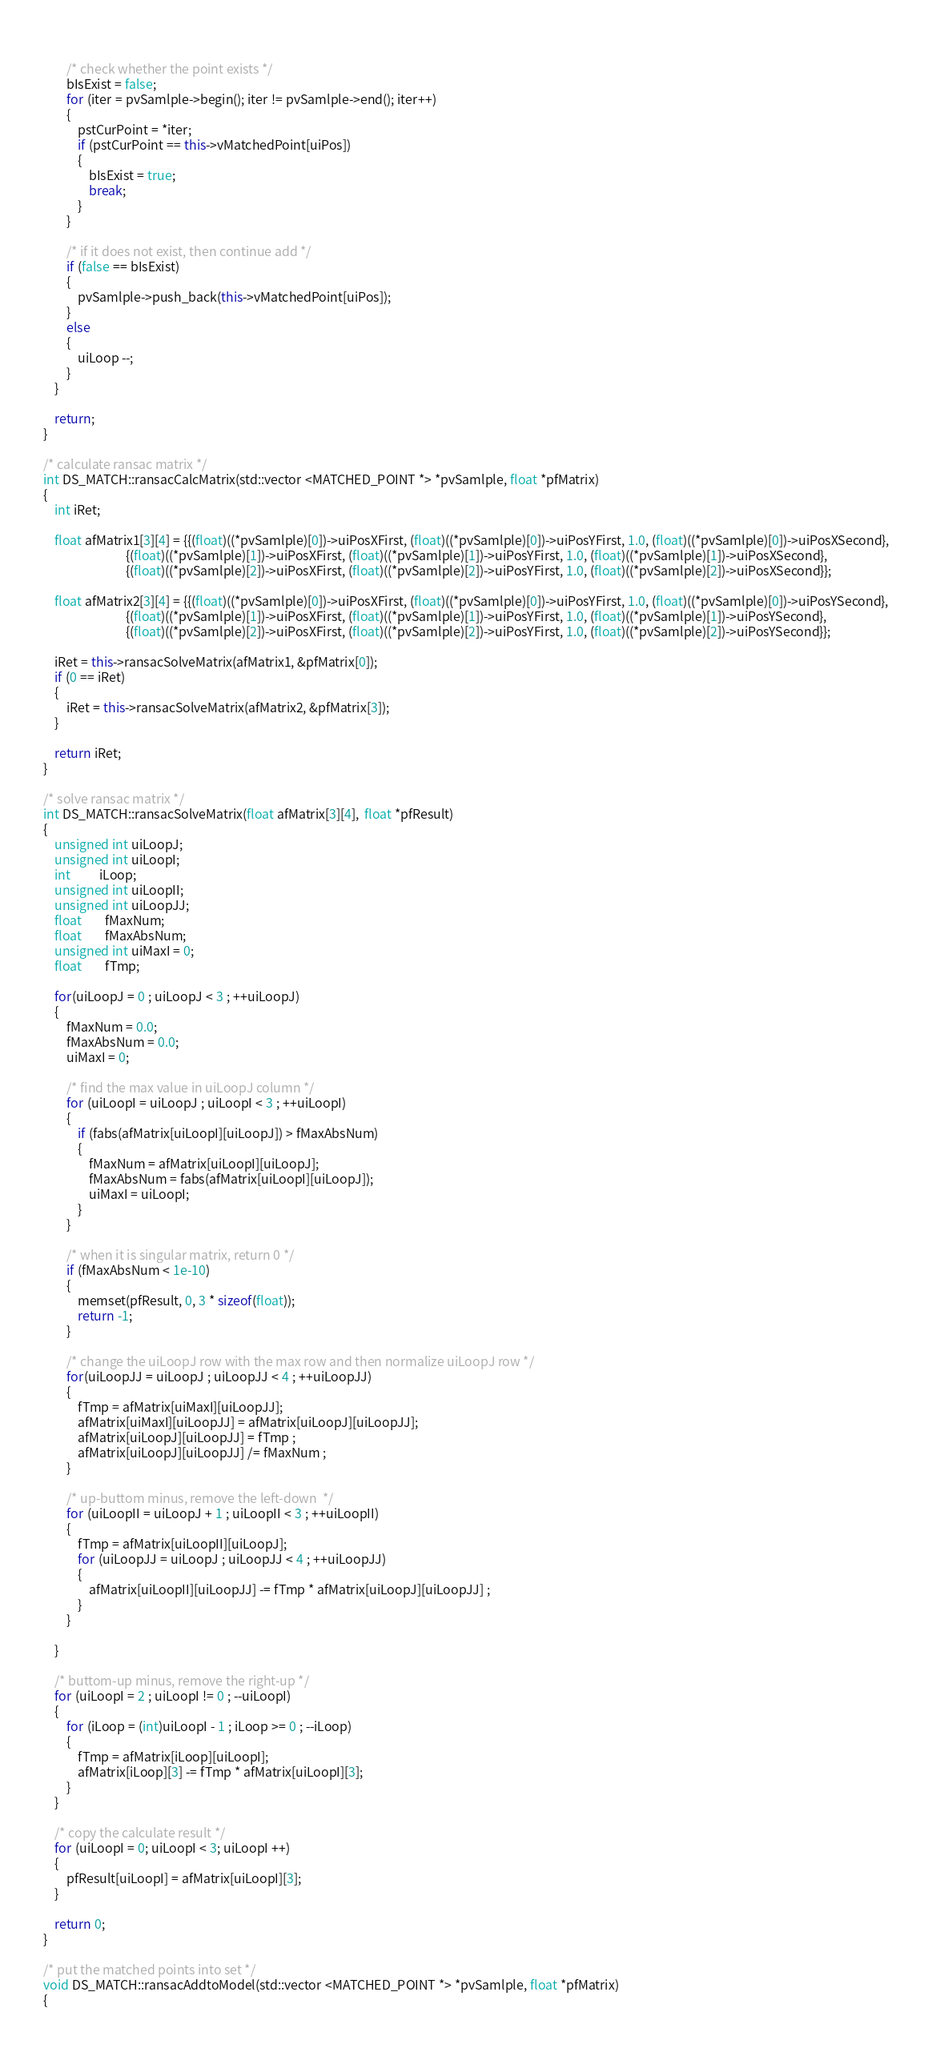Convert code to text. <code><loc_0><loc_0><loc_500><loc_500><_C++_>        
        /* check whether the point exists */
        bIsExist = false;
        for (iter = pvSamlple->begin(); iter != pvSamlple->end(); iter++)
        {
            pstCurPoint = *iter;
            if (pstCurPoint == this->vMatchedPoint[uiPos])
            {
                bIsExist = true;
                break;
            }
        }

        /* if it does not exist, then continue add */
        if (false == bIsExist)
        {
            pvSamlple->push_back(this->vMatchedPoint[uiPos]);
        }
        else
        {
            uiLoop --;
        }
    }

    return;
}

/* calculate ransac matrix */
int DS_MATCH::ransacCalcMatrix(std::vector <MATCHED_POINT *> *pvSamlple, float *pfMatrix)
{
    int iRet;

    float afMatrix1[3][4] = {{(float)((*pvSamlple)[0])->uiPosXFirst, (float)((*pvSamlple)[0])->uiPosYFirst, 1.0, (float)((*pvSamlple)[0])->uiPosXSecond},
                             {(float)((*pvSamlple)[1])->uiPosXFirst, (float)((*pvSamlple)[1])->uiPosYFirst, 1.0, (float)((*pvSamlple)[1])->uiPosXSecond},
                             {(float)((*pvSamlple)[2])->uiPosXFirst, (float)((*pvSamlple)[2])->uiPosYFirst, 1.0, (float)((*pvSamlple)[2])->uiPosXSecond}};

    float afMatrix2[3][4] = {{(float)((*pvSamlple)[0])->uiPosXFirst, (float)((*pvSamlple)[0])->uiPosYFirst, 1.0, (float)((*pvSamlple)[0])->uiPosYSecond},
                             {(float)((*pvSamlple)[1])->uiPosXFirst, (float)((*pvSamlple)[1])->uiPosYFirst, 1.0, (float)((*pvSamlple)[1])->uiPosYSecond},
                             {(float)((*pvSamlple)[2])->uiPosXFirst, (float)((*pvSamlple)[2])->uiPosYFirst, 1.0, (float)((*pvSamlple)[2])->uiPosYSecond}};

    iRet = this->ransacSolveMatrix(afMatrix1, &pfMatrix[0]);
    if (0 == iRet)
    {
        iRet = this->ransacSolveMatrix(afMatrix2, &pfMatrix[3]);
    }

    return iRet;
}

/* solve ransac matrix */
int DS_MATCH::ransacSolveMatrix(float afMatrix[3][4],  float *pfResult)
{
    unsigned int uiLoopJ;
    unsigned int uiLoopI;
    int          iLoop;
    unsigned int uiLoopII;
    unsigned int uiLoopJJ;
    float        fMaxNum;
    float        fMaxAbsNum;
    unsigned int uiMaxI = 0;
    float        fTmp;

    for(uiLoopJ = 0 ; uiLoopJ < 3 ; ++uiLoopJ) 
    {
        fMaxNum = 0.0;
        fMaxAbsNum = 0.0;
        uiMaxI = 0;

        /* find the max value in uiLoopJ column */
        for (uiLoopI = uiLoopJ ; uiLoopI < 3 ; ++uiLoopI) 
        {
            if (fabs(afMatrix[uiLoopI][uiLoopJ]) > fMaxAbsNum) 
            {
                fMaxNum = afMatrix[uiLoopI][uiLoopJ];
                fMaxAbsNum = fabs(afMatrix[uiLoopI][uiLoopJ]);
                uiMaxI = uiLoopI;
            }
        }

        /* when it is singular matrix, return 0 */
        if (fMaxAbsNum < 1e-10)
        {
            memset(pfResult, 0, 3 * sizeof(float));
            return -1;
        }

        /* change the uiLoopJ row with the max row and then normalize uiLoopJ row */
        for(uiLoopJJ = uiLoopJ ; uiLoopJJ < 4 ; ++uiLoopJJ)
        {
            fTmp = afMatrix[uiMaxI][uiLoopJJ];
            afMatrix[uiMaxI][uiLoopJJ] = afMatrix[uiLoopJ][uiLoopJJ];
            afMatrix[uiLoopJ][uiLoopJJ] = fTmp ;
            afMatrix[uiLoopJ][uiLoopJJ] /= fMaxNum ;
        }

        /* up-buttom minus, remove the left-down  */
        for (uiLoopII = uiLoopJ + 1 ; uiLoopII < 3 ; ++uiLoopII)
        {
            fTmp = afMatrix[uiLoopII][uiLoopJ];
            for (uiLoopJJ = uiLoopJ ; uiLoopJJ < 4 ; ++uiLoopJJ)
            {
                afMatrix[uiLoopII][uiLoopJJ] -= fTmp * afMatrix[uiLoopJ][uiLoopJJ] ;
            }
        }

    }

    /* buttom-up minus, remove the right-up */
    for (uiLoopI = 2 ; uiLoopI != 0 ; --uiLoopI) 
    {
        for (iLoop = (int)uiLoopI - 1 ; iLoop >= 0 ; --iLoop)
        {
            fTmp = afMatrix[iLoop][uiLoopI];
            afMatrix[iLoop][3] -= fTmp * afMatrix[uiLoopI][3];
        }
    }

    /* copy the calculate result */
    for (uiLoopI = 0; uiLoopI < 3; uiLoopI ++)
    {
        pfResult[uiLoopI] = afMatrix[uiLoopI][3];
    }

    return 0;
}

/* put the matched points into set */
void DS_MATCH::ransacAddtoModel(std::vector <MATCHED_POINT *> *pvSamlple, float *pfMatrix)
{</code> 